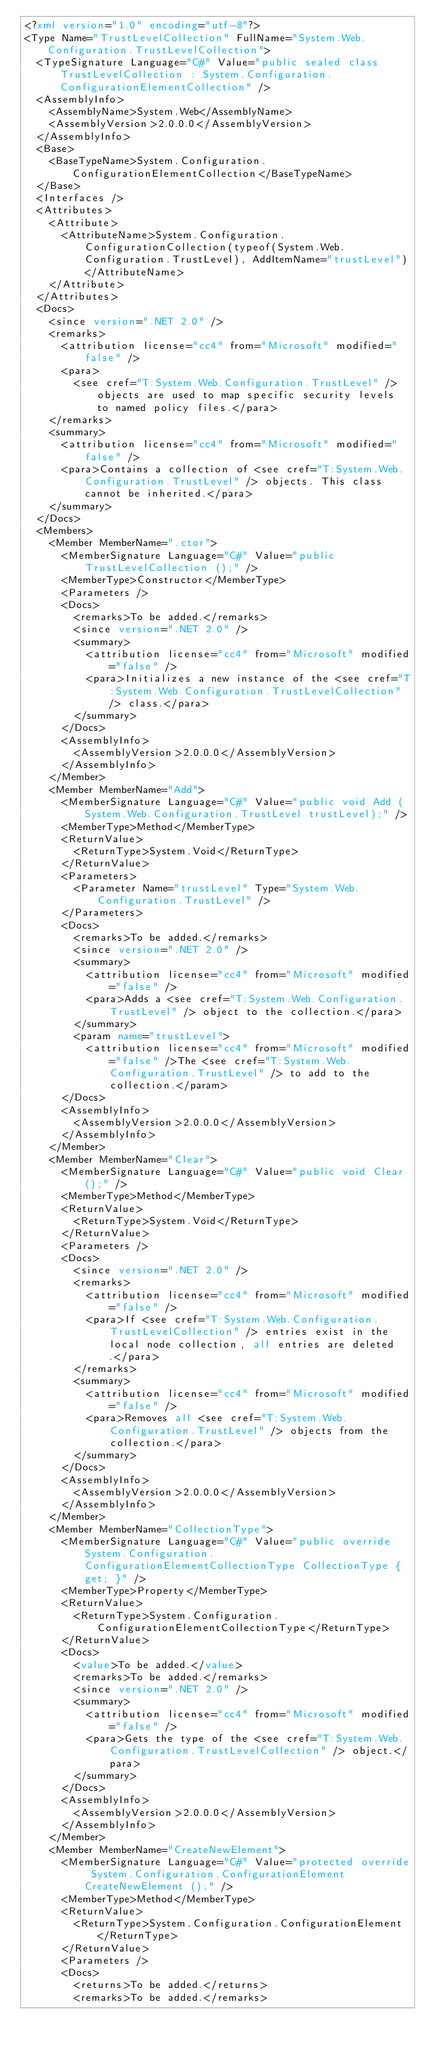<code> <loc_0><loc_0><loc_500><loc_500><_XML_><?xml version="1.0" encoding="utf-8"?>
<Type Name="TrustLevelCollection" FullName="System.Web.Configuration.TrustLevelCollection">
  <TypeSignature Language="C#" Value="public sealed class TrustLevelCollection : System.Configuration.ConfigurationElementCollection" />
  <AssemblyInfo>
    <AssemblyName>System.Web</AssemblyName>
    <AssemblyVersion>2.0.0.0</AssemblyVersion>
  </AssemblyInfo>
  <Base>
    <BaseTypeName>System.Configuration.ConfigurationElementCollection</BaseTypeName>
  </Base>
  <Interfaces />
  <Attributes>
    <Attribute>
      <AttributeName>System.Configuration.ConfigurationCollection(typeof(System.Web.Configuration.TrustLevel), AddItemName="trustLevel")</AttributeName>
    </Attribute>
  </Attributes>
  <Docs>
    <since version=".NET 2.0" />
    <remarks>
      <attribution license="cc4" from="Microsoft" modified="false" />
      <para>
        <see cref="T:System.Web.Configuration.TrustLevel" /> objects are used to map specific security levels to named policy files.</para>
    </remarks>
    <summary>
      <attribution license="cc4" from="Microsoft" modified="false" />
      <para>Contains a collection of <see cref="T:System.Web.Configuration.TrustLevel" /> objects. This class cannot be inherited.</para>
    </summary>
  </Docs>
  <Members>
    <Member MemberName=".ctor">
      <MemberSignature Language="C#" Value="public TrustLevelCollection ();" />
      <MemberType>Constructor</MemberType>
      <Parameters />
      <Docs>
        <remarks>To be added.</remarks>
        <since version=".NET 2.0" />
        <summary>
          <attribution license="cc4" from="Microsoft" modified="false" />
          <para>Initializes a new instance of the <see cref="T:System.Web.Configuration.TrustLevelCollection" /> class.</para>
        </summary>
      </Docs>
      <AssemblyInfo>
        <AssemblyVersion>2.0.0.0</AssemblyVersion>
      </AssemblyInfo>
    </Member>
    <Member MemberName="Add">
      <MemberSignature Language="C#" Value="public void Add (System.Web.Configuration.TrustLevel trustLevel);" />
      <MemberType>Method</MemberType>
      <ReturnValue>
        <ReturnType>System.Void</ReturnType>
      </ReturnValue>
      <Parameters>
        <Parameter Name="trustLevel" Type="System.Web.Configuration.TrustLevel" />
      </Parameters>
      <Docs>
        <remarks>To be added.</remarks>
        <since version=".NET 2.0" />
        <summary>
          <attribution license="cc4" from="Microsoft" modified="false" />
          <para>Adds a <see cref="T:System.Web.Configuration.TrustLevel" /> object to the collection.</para>
        </summary>
        <param name="trustLevel">
          <attribution license="cc4" from="Microsoft" modified="false" />The <see cref="T:System.Web.Configuration.TrustLevel" /> to add to the collection.</param>
      </Docs>
      <AssemblyInfo>
        <AssemblyVersion>2.0.0.0</AssemblyVersion>
      </AssemblyInfo>
    </Member>
    <Member MemberName="Clear">
      <MemberSignature Language="C#" Value="public void Clear ();" />
      <MemberType>Method</MemberType>
      <ReturnValue>
        <ReturnType>System.Void</ReturnType>
      </ReturnValue>
      <Parameters />
      <Docs>
        <since version=".NET 2.0" />
        <remarks>
          <attribution license="cc4" from="Microsoft" modified="false" />
          <para>If <see cref="T:System.Web.Configuration.TrustLevelCollection" /> entries exist in the local node collection, all entries are deleted.</para>
        </remarks>
        <summary>
          <attribution license="cc4" from="Microsoft" modified="false" />
          <para>Removes all <see cref="T:System.Web.Configuration.TrustLevel" /> objects from the collection.</para>
        </summary>
      </Docs>
      <AssemblyInfo>
        <AssemblyVersion>2.0.0.0</AssemblyVersion>
      </AssemblyInfo>
    </Member>
    <Member MemberName="CollectionType">
      <MemberSignature Language="C#" Value="public override System.Configuration.ConfigurationElementCollectionType CollectionType { get; }" />
      <MemberType>Property</MemberType>
      <ReturnValue>
        <ReturnType>System.Configuration.ConfigurationElementCollectionType</ReturnType>
      </ReturnValue>
      <Docs>
        <value>To be added.</value>
        <remarks>To be added.</remarks>
        <since version=".NET 2.0" />
        <summary>
          <attribution license="cc4" from="Microsoft" modified="false" />
          <para>Gets the type of the <see cref="T:System.Web.Configuration.TrustLevelCollection" /> object.</para>
        </summary>
      </Docs>
      <AssemblyInfo>
        <AssemblyVersion>2.0.0.0</AssemblyVersion>
      </AssemblyInfo>
    </Member>
    <Member MemberName="CreateNewElement">
      <MemberSignature Language="C#" Value="protected override System.Configuration.ConfigurationElement CreateNewElement ();" />
      <MemberType>Method</MemberType>
      <ReturnValue>
        <ReturnType>System.Configuration.ConfigurationElement</ReturnType>
      </ReturnValue>
      <Parameters />
      <Docs>
        <returns>To be added.</returns>
        <remarks>To be added.</remarks></code> 